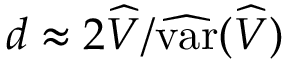Convert formula to latex. <formula><loc_0><loc_0><loc_500><loc_500>d \approx 2 \widehat { V } / \widehat { v a r } ( \widehat { V } )</formula> 